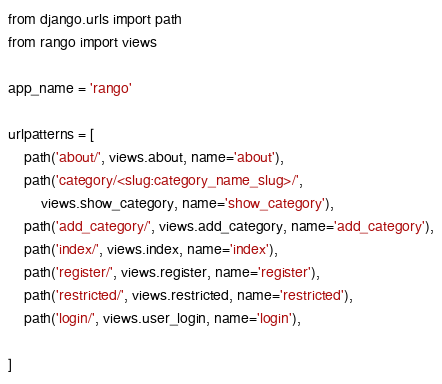<code> <loc_0><loc_0><loc_500><loc_500><_Python_>from django.urls import path
from rango import views

app_name = 'rango'

urlpatterns = [
	path('about/', views.about, name='about'),
	path('category/<slug:category_name_slug>/', 
		views.show_category, name='show_category'),
	path('add_category/', views.add_category, name='add_category'),
	path('index/', views.index, name='index'),
	path('register/', views.register, name='register'),
	path('restricted/', views.restricted, name='restricted'),
	path('login/', views.user_login, name='login'),

]</code> 